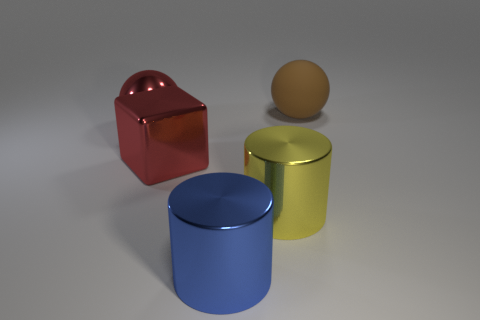Add 5 big blue cylinders. How many objects exist? 10 Subtract all blocks. How many objects are left? 4 Add 3 blue metallic cylinders. How many blue metallic cylinders exist? 4 Subtract 0 blue cubes. How many objects are left? 5 Subtract all large yellow objects. Subtract all spheres. How many objects are left? 2 Add 4 big rubber balls. How many big rubber balls are left? 5 